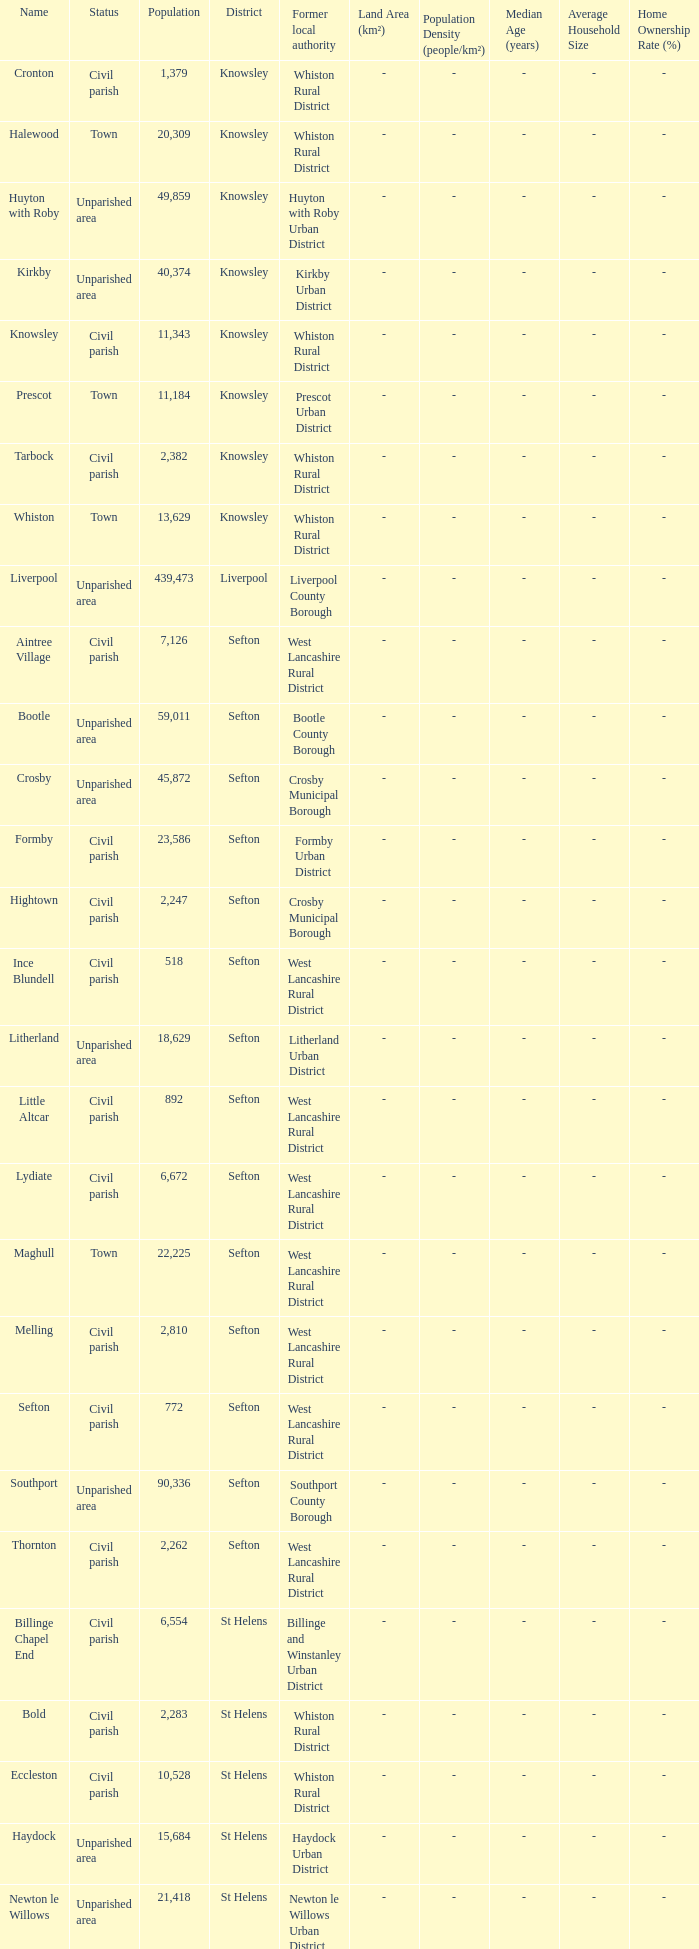What is the district of wallasey Wirral. 